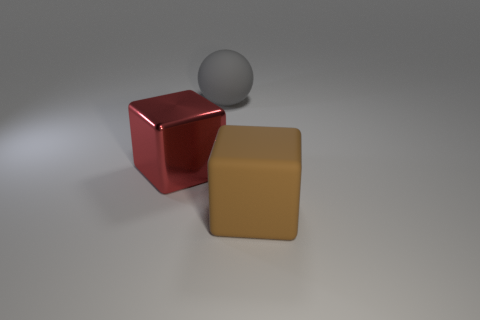Subtract all brown cubes. How many cubes are left? 1 Subtract 1 cubes. How many cubes are left? 1 Subtract all cubes. How many objects are left? 1 Add 1 big cubes. How many objects exist? 4 Add 1 big spheres. How many big spheres exist? 2 Subtract 1 brown cubes. How many objects are left? 2 Subtract all purple spheres. Subtract all blue cylinders. How many spheres are left? 1 Subtract all large matte objects. Subtract all red metal blocks. How many objects are left? 0 Add 2 shiny cubes. How many shiny cubes are left? 3 